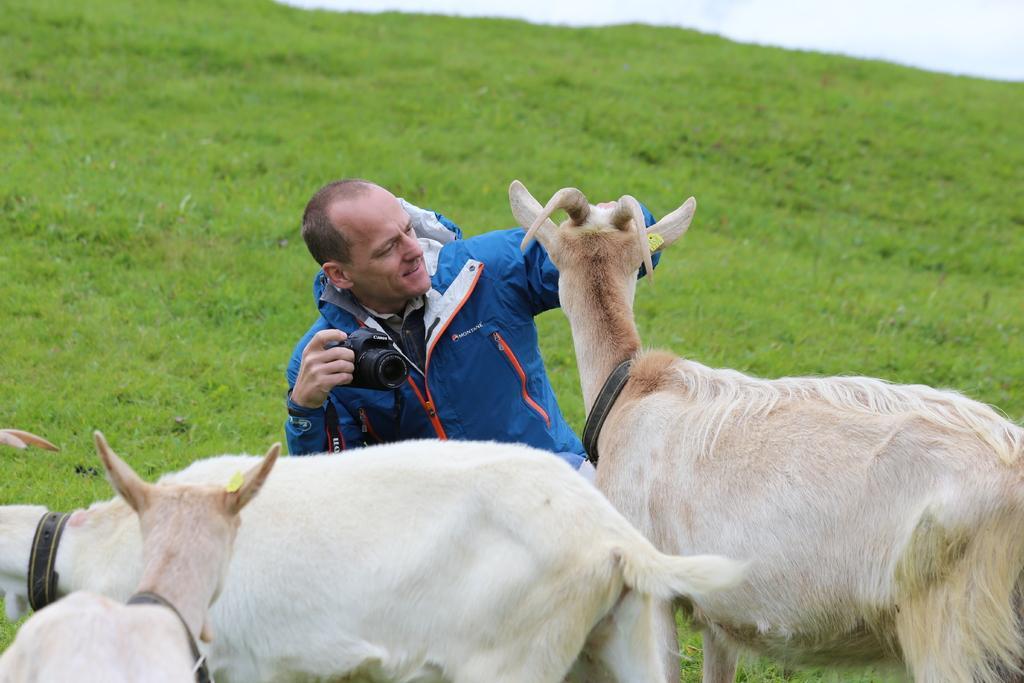Describe this image in one or two sentences. This image is taken outdoors. At the top of the image there is the sky with clouds. At the bottom of the image there are three goats on the ground. In the middle of the image there is a man and he is holding a camera in his hand. In the background there is a ground with grass on it. 